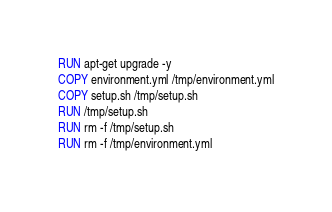<code> <loc_0><loc_0><loc_500><loc_500><_Dockerfile_>RUN apt-get upgrade -y
COPY environment.yml /tmp/environment.yml
COPY setup.sh /tmp/setup.sh
RUN /tmp/setup.sh
RUN rm -f /tmp/setup.sh
RUN rm -f /tmp/environment.yml
</code> 